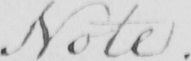What is written in this line of handwriting? Note . 